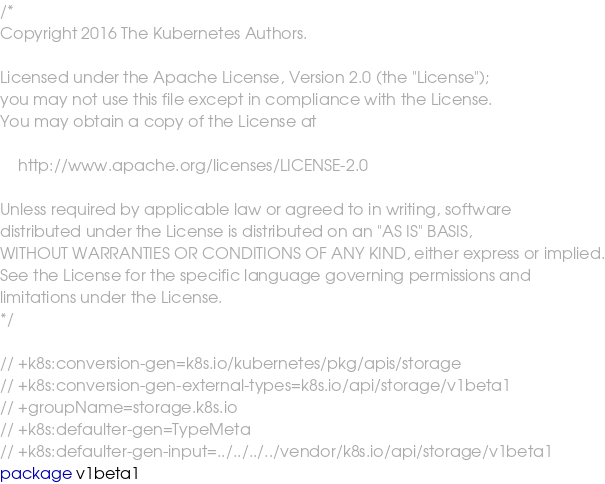Convert code to text. <code><loc_0><loc_0><loc_500><loc_500><_Go_>/*
Copyright 2016 The Kubernetes Authors.

Licensed under the Apache License, Version 2.0 (the "License");
you may not use this file except in compliance with the License.
You may obtain a copy of the License at

    http://www.apache.org/licenses/LICENSE-2.0

Unless required by applicable law or agreed to in writing, software
distributed under the License is distributed on an "AS IS" BASIS,
WITHOUT WARRANTIES OR CONDITIONS OF ANY KIND, either express or implied.
See the License for the specific language governing permissions and
limitations under the License.
*/

// +k8s:conversion-gen=k8s.io/kubernetes/pkg/apis/storage
// +k8s:conversion-gen-external-types=k8s.io/api/storage/v1beta1
// +groupName=storage.k8s.io
// +k8s:defaulter-gen=TypeMeta
// +k8s:defaulter-gen-input=../../../../vendor/k8s.io/api/storage/v1beta1
package v1beta1
</code> 